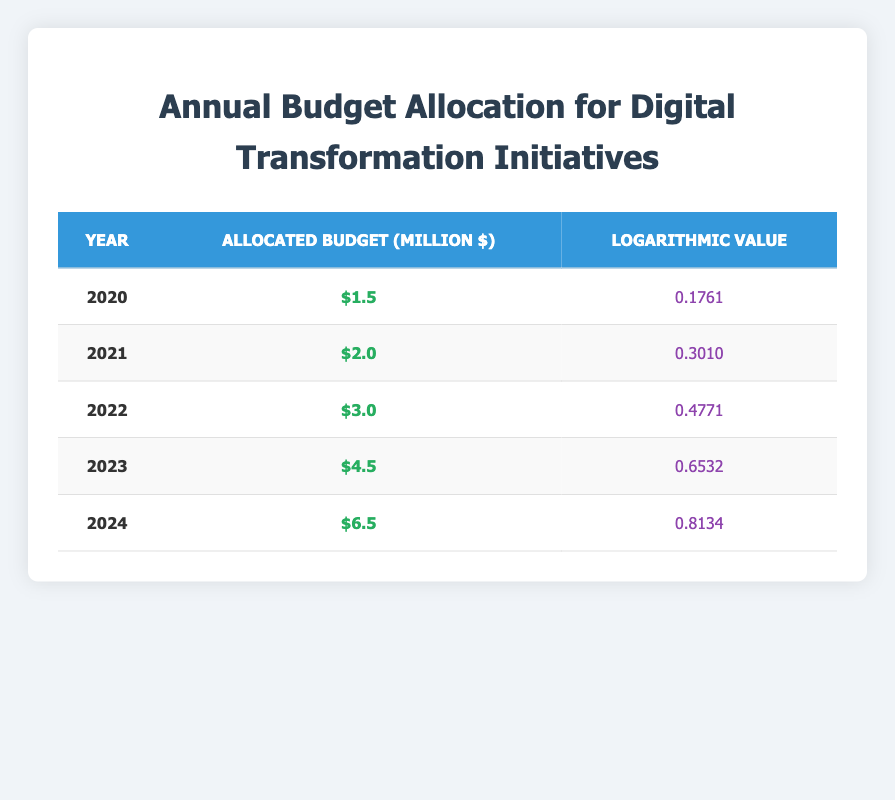What was the allocated budget for digital transformation in 2021? According to the table, the allocated budget for the year 2021 is $2.0 million as indicated in the corresponding row.
Answer: $2.0 million Which year had the highest allocated budget? Examining the allocated budgets across all the years, the highest value is $6.5 million in 2024.
Answer: 2024 What is the logarithmic value for a budget of $4.5 million? Looking at the row for the year 2023, the logarithmic value corresponding to a budget of $4.5 million is 0.6532.
Answer: 0.6532 What is the difference between the allocated budgets of 2022 and 2023? The budget for 2022 is $3.0 million and for 2023 is $4.5 million. The difference is calculated as $4.5 million - $3.0 million = $1.5 million.
Answer: $1.5 million Is the logarithmic value for the budget in 2020 higher than that for 2024? The logarithmic value for 2020 is 0.1761 and for 2024 it is 0.8134. Since 0.1761 is less than 0.8134, the statement is false.
Answer: No What was the average allocated budget from 2020 to 2024? The allocated budgets are $1.5 million, $2.0 million, $3.0 million, $4.5 million, and $6.5 million. Summing these gives $17.5 million. There are 5 data points, so the average is $17.5 million / 5 = $3.5 million.
Answer: $3.5 million How much did the allocated budget grow from 2020 to 2024? The budget in 2020 was $1.5 million, and in 2024 it is $6.5 million. The growth is calculated as $6.5 million - $1.5 million = $5.0 million.
Answer: $5.0 million In which year did the logarithmic value exceed 0.5? By examining the logarithmic values, we see that 0.5 is exceeded in the years 2022 (0.4771), 2023 (0.6532), and 2024 (0.8134). Thus, the years when it exceeded 0.5 are 2023 and 2024.
Answer: 2023 and 2024 What is the total allocated budget over the five years listed? The budgets are $1.5 million, $2.0 million, $3.0 million, $4.5 million, and $6.5 million. Adding these together gives a total of $17.5 million.
Answer: $17.5 million 